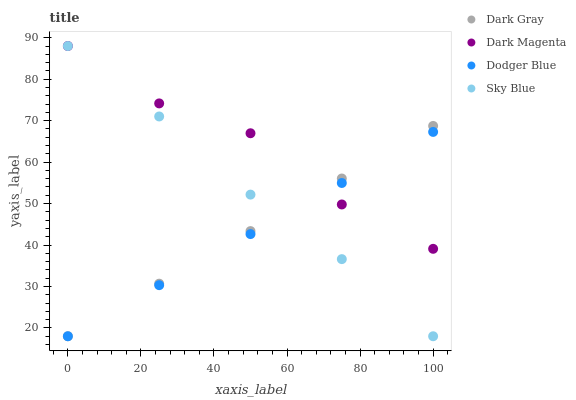Does Dodger Blue have the minimum area under the curve?
Answer yes or no. Yes. Does Dark Magenta have the maximum area under the curve?
Answer yes or no. Yes. Does Sky Blue have the minimum area under the curve?
Answer yes or no. No. Does Sky Blue have the maximum area under the curve?
Answer yes or no. No. Is Dark Gray the smoothest?
Answer yes or no. Yes. Is Dark Magenta the roughest?
Answer yes or no. Yes. Is Sky Blue the smoothest?
Answer yes or no. No. Is Sky Blue the roughest?
Answer yes or no. No. Does Dark Gray have the lowest value?
Answer yes or no. Yes. Does Dark Magenta have the lowest value?
Answer yes or no. No. Does Dark Magenta have the highest value?
Answer yes or no. Yes. Does Dodger Blue have the highest value?
Answer yes or no. No. Does Sky Blue intersect Dodger Blue?
Answer yes or no. Yes. Is Sky Blue less than Dodger Blue?
Answer yes or no. No. Is Sky Blue greater than Dodger Blue?
Answer yes or no. No. 